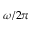Convert formula to latex. <formula><loc_0><loc_0><loc_500><loc_500>\omega / 2 \pi</formula> 